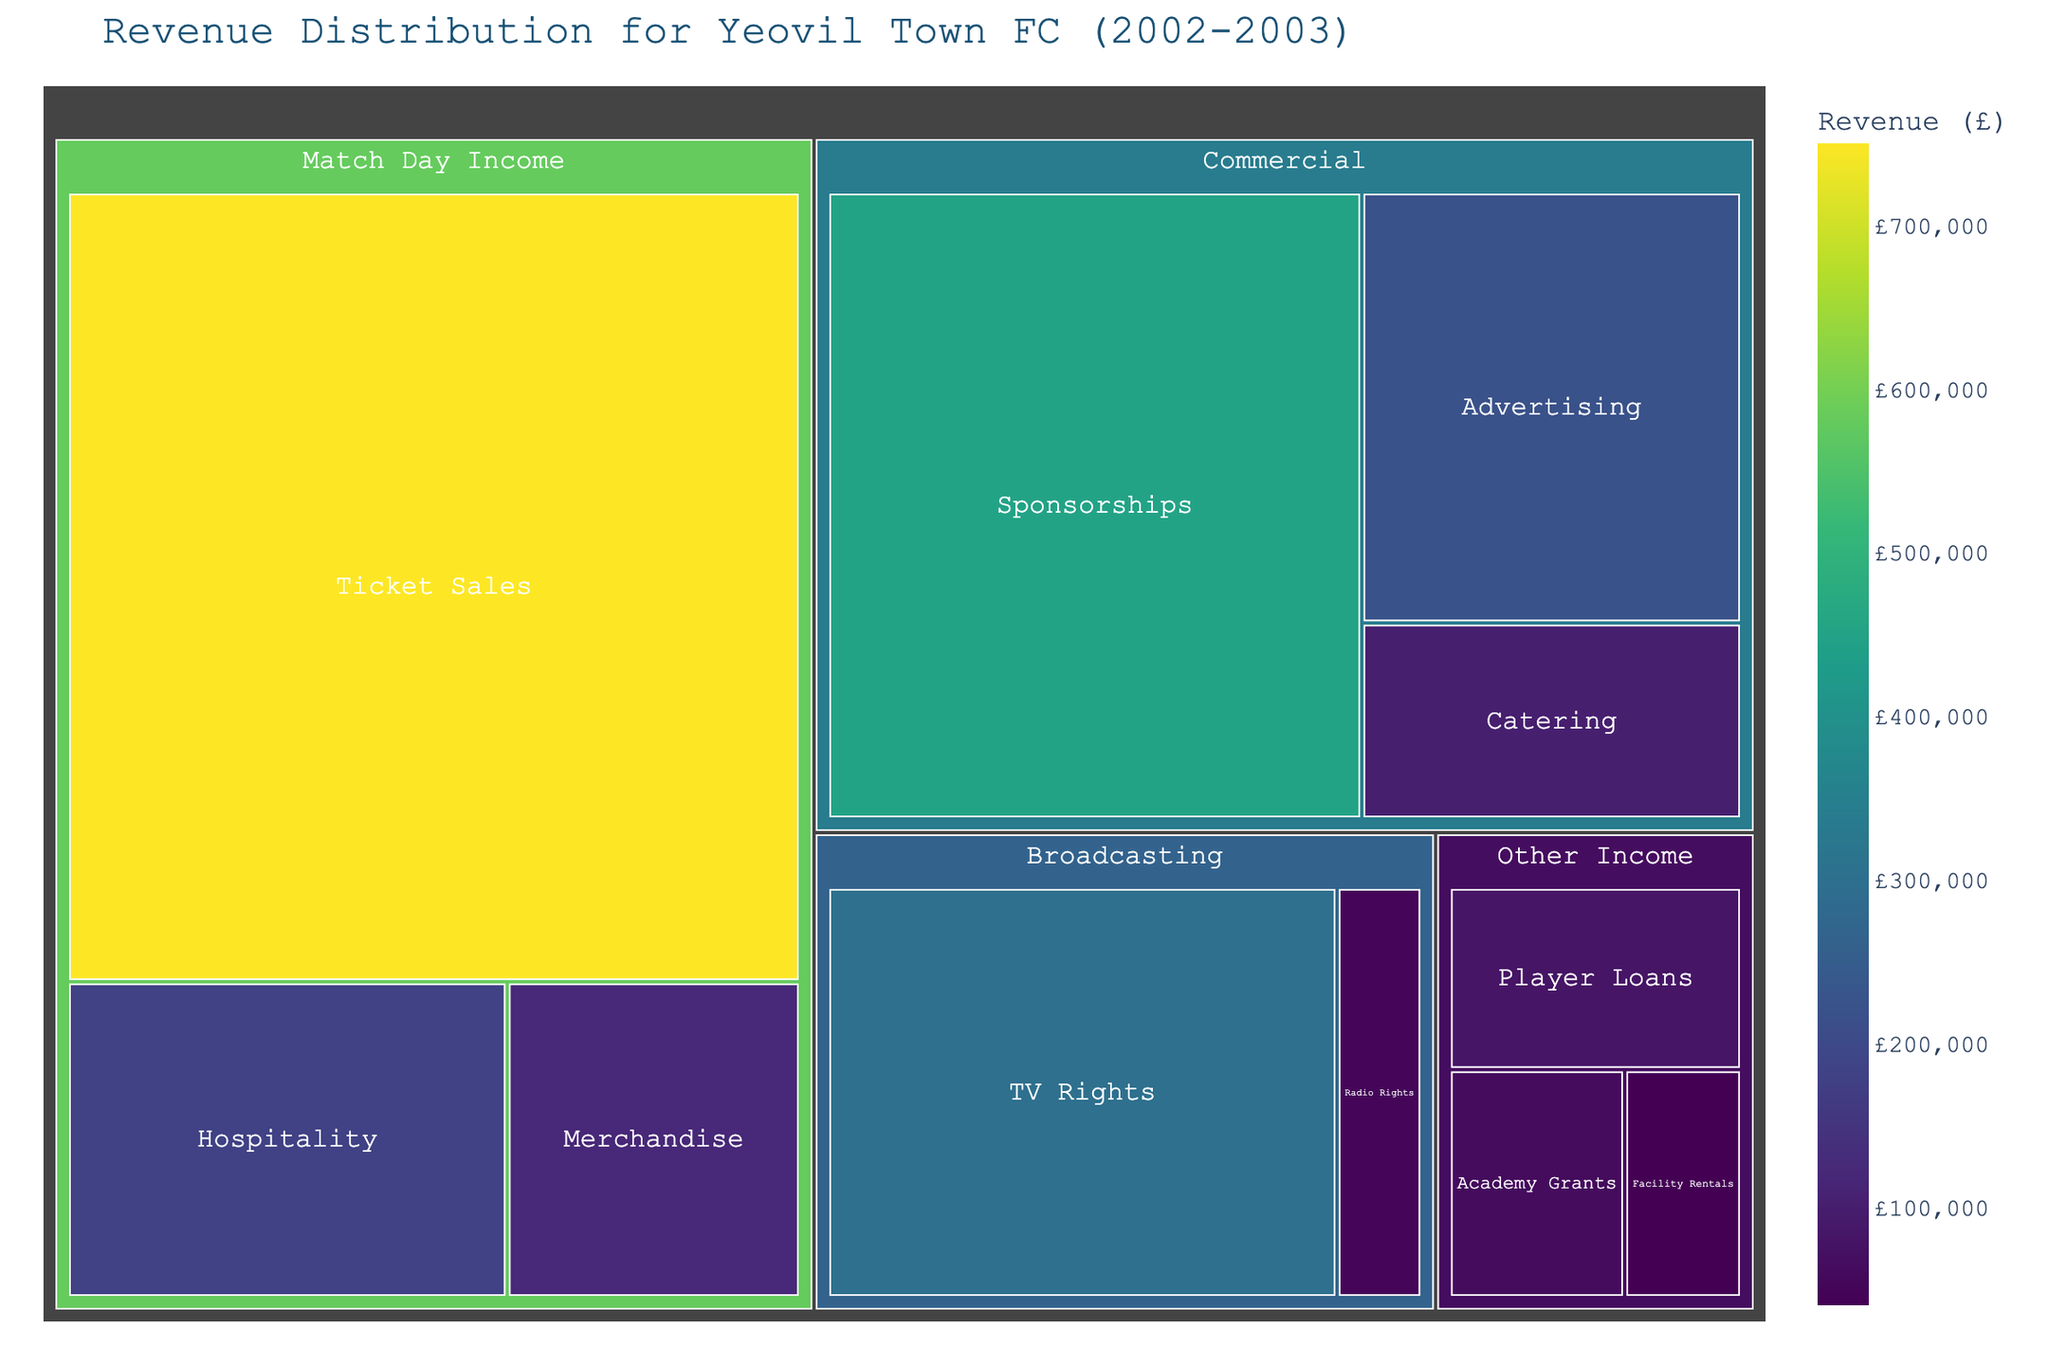What is the largest source of revenue for Yeovil Town FC in 2002-2003? The largest box in the treemap represents the highest revenue source. The "Ticket Sales" box under the "Match Day Income" category is the largest.
Answer: Ticket Sales How much revenue did the "Commercial" category generate in total? Add the values of the subcategories under "Commercial": Sponsorships (£450,000) + Advertising (£220,000) + Catering (£100,000).
Answer: £770,000 Compare the revenue from "TV Rights" and "Radio Rights". Which one is higher and by how much? The "TV Rights" revenue is £300,000, and the "Radio Rights" revenue is £50,000. The difference is £300,000 - £50,000.
Answer: TV Rights is higher by £250,000 What percentage of the total "Match Day Income" comes from "Hospitality"? The total "Match Day Income" is £750,000 (Ticket Sales) + £180,000 (Hospitality) + £120,000 (Merchandise) = £1,050,000. The percentage for "Hospitality" is ( £180,000 / £1,050,000 ) * 100%.
Answer: 17.14% Which category has more subcategories: "Broadcasting" or "Other Income"? "Broadcasting" has two subcategories (TV Rights, Radio Rights) while "Other Income" has three subcategories (Player Loans, Academy Grants, Facility Rentals).
Answer: Other Income What is the combined revenue from all "Broadcasting" sources? Add the revenues from "TV Rights" (£300,000) and "Radio Rights" (£50,000).
Answer: £350,000 How does the revenue from "Player Loans" compare to "Academy Grants"? The "Player Loans" revenue is £80,000, and the "Academy Grants" revenue is £60,000. "Player Loans" is higher.
Answer: Player Loans is higher Identify the lowest revenue subcategory and its value. The smallest box in the treemap represents the lowest revenue subcategory, which is "Facility Rentals" with a value of £40,000.
Answer: Facility Rentals, £40,000 Calculate the total revenue generated by "Match Day Income" and "Broadcasting" categories combined. Sum the total revenues from "Match Day Income" (£1,050,000) and "Broadcasting" (£350,000).
Answer: £1,400,000 